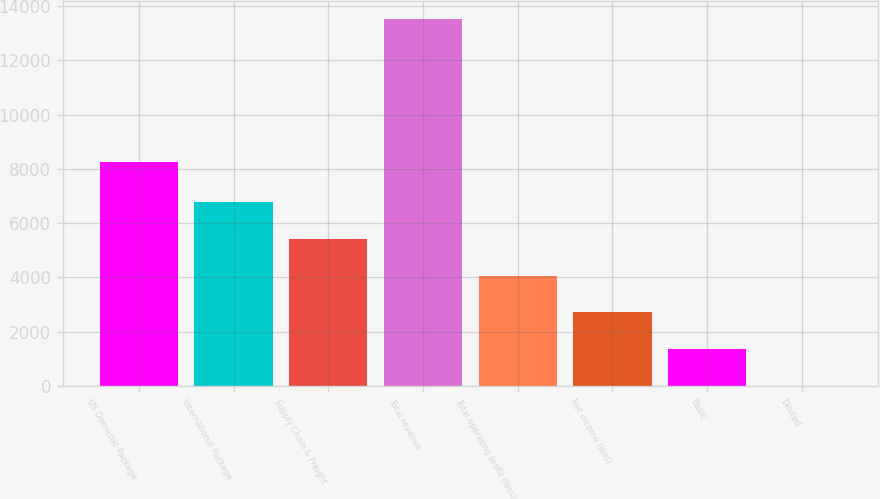Convert chart. <chart><loc_0><loc_0><loc_500><loc_500><bar_chart><fcel>US Domestic Package<fcel>International Package<fcel>Supply Chain & Freight<fcel>Total revenue<fcel>Total operating profit (loss)<fcel>Net income (loss)<fcel>Basic<fcel>Diluted<nl><fcel>8254<fcel>6761.06<fcel>5409.08<fcel>13521<fcel>4057.1<fcel>2705.12<fcel>1353.14<fcel>1.16<nl></chart> 